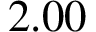<formula> <loc_0><loc_0><loc_500><loc_500>2 . 0 0</formula> 